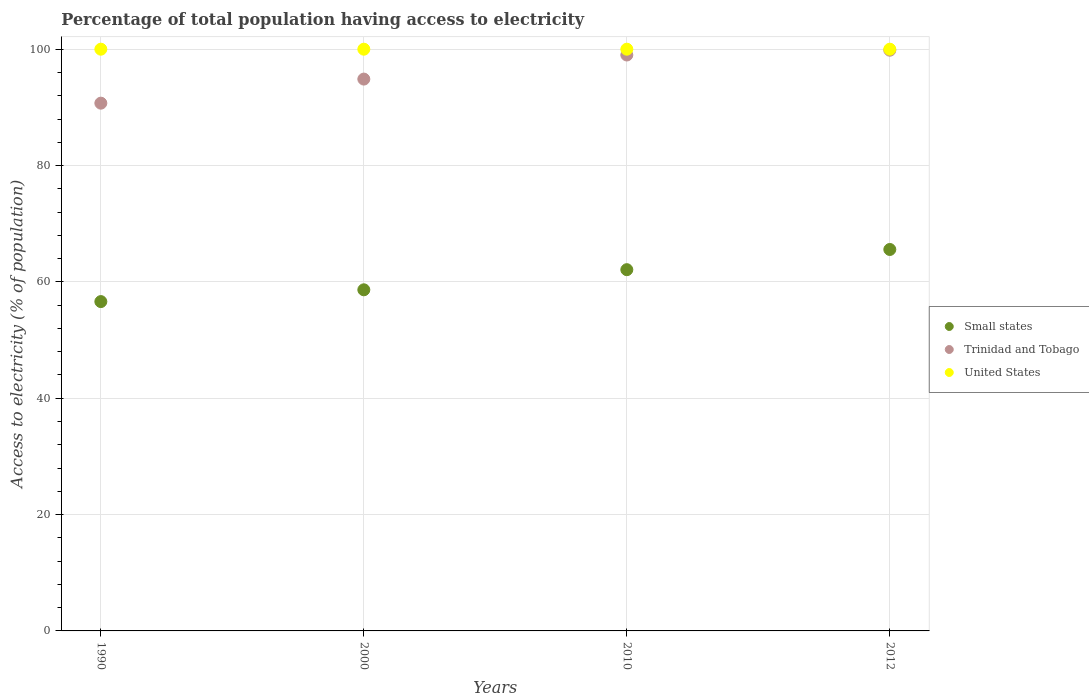What is the percentage of population that have access to electricity in Small states in 2000?
Your answer should be very brief. 58.64. Across all years, what is the maximum percentage of population that have access to electricity in Small states?
Make the answer very short. 65.57. Across all years, what is the minimum percentage of population that have access to electricity in Small states?
Ensure brevity in your answer.  56.61. In which year was the percentage of population that have access to electricity in Trinidad and Tobago maximum?
Provide a short and direct response. 2012. In which year was the percentage of population that have access to electricity in Small states minimum?
Make the answer very short. 1990. What is the total percentage of population that have access to electricity in United States in the graph?
Give a very brief answer. 400. What is the difference between the percentage of population that have access to electricity in United States in 1990 and that in 2012?
Ensure brevity in your answer.  0. What is the difference between the percentage of population that have access to electricity in Trinidad and Tobago in 2000 and the percentage of population that have access to electricity in Small states in 1990?
Ensure brevity in your answer.  38.25. What is the average percentage of population that have access to electricity in Small states per year?
Give a very brief answer. 60.73. In the year 1990, what is the difference between the percentage of population that have access to electricity in Small states and percentage of population that have access to electricity in Trinidad and Tobago?
Make the answer very short. -34.11. In how many years, is the percentage of population that have access to electricity in Small states greater than 40 %?
Provide a short and direct response. 4. What is the difference between the highest and the second highest percentage of population that have access to electricity in Trinidad and Tobago?
Your answer should be compact. 0.83. What is the difference between the highest and the lowest percentage of population that have access to electricity in United States?
Offer a terse response. 0. Is it the case that in every year, the sum of the percentage of population that have access to electricity in Small states and percentage of population that have access to electricity in Trinidad and Tobago  is greater than the percentage of population that have access to electricity in United States?
Your answer should be very brief. Yes. Is the percentage of population that have access to electricity in United States strictly less than the percentage of population that have access to electricity in Trinidad and Tobago over the years?
Your answer should be very brief. No. Does the graph contain grids?
Your answer should be very brief. Yes. How many legend labels are there?
Your answer should be very brief. 3. What is the title of the graph?
Your answer should be very brief. Percentage of total population having access to electricity. Does "Myanmar" appear as one of the legend labels in the graph?
Make the answer very short. No. What is the label or title of the X-axis?
Ensure brevity in your answer.  Years. What is the label or title of the Y-axis?
Provide a succinct answer. Access to electricity (% of population). What is the Access to electricity (% of population) of Small states in 1990?
Your answer should be compact. 56.61. What is the Access to electricity (% of population) in Trinidad and Tobago in 1990?
Give a very brief answer. 90.72. What is the Access to electricity (% of population) of United States in 1990?
Offer a terse response. 100. What is the Access to electricity (% of population) of Small states in 2000?
Provide a succinct answer. 58.64. What is the Access to electricity (% of population) in Trinidad and Tobago in 2000?
Offer a very short reply. 94.86. What is the Access to electricity (% of population) of Small states in 2010?
Provide a succinct answer. 62.1. What is the Access to electricity (% of population) in Trinidad and Tobago in 2010?
Offer a very short reply. 99. What is the Access to electricity (% of population) in Small states in 2012?
Ensure brevity in your answer.  65.57. What is the Access to electricity (% of population) of Trinidad and Tobago in 2012?
Your answer should be compact. 99.83. What is the Access to electricity (% of population) in United States in 2012?
Your answer should be compact. 100. Across all years, what is the maximum Access to electricity (% of population) in Small states?
Offer a terse response. 65.57. Across all years, what is the maximum Access to electricity (% of population) of Trinidad and Tobago?
Give a very brief answer. 99.83. Across all years, what is the maximum Access to electricity (% of population) in United States?
Ensure brevity in your answer.  100. Across all years, what is the minimum Access to electricity (% of population) in Small states?
Provide a succinct answer. 56.61. Across all years, what is the minimum Access to electricity (% of population) of Trinidad and Tobago?
Make the answer very short. 90.72. Across all years, what is the minimum Access to electricity (% of population) in United States?
Keep it short and to the point. 100. What is the total Access to electricity (% of population) of Small states in the graph?
Your response must be concise. 242.92. What is the total Access to electricity (% of population) in Trinidad and Tobago in the graph?
Give a very brief answer. 384.41. What is the total Access to electricity (% of population) in United States in the graph?
Your answer should be compact. 400. What is the difference between the Access to electricity (% of population) of Small states in 1990 and that in 2000?
Your answer should be compact. -2.03. What is the difference between the Access to electricity (% of population) of Trinidad and Tobago in 1990 and that in 2000?
Keep it short and to the point. -4.14. What is the difference between the Access to electricity (% of population) in Small states in 1990 and that in 2010?
Your answer should be compact. -5.49. What is the difference between the Access to electricity (% of population) in Trinidad and Tobago in 1990 and that in 2010?
Provide a short and direct response. -8.28. What is the difference between the Access to electricity (% of population) in Small states in 1990 and that in 2012?
Your response must be concise. -8.96. What is the difference between the Access to electricity (% of population) of Trinidad and Tobago in 1990 and that in 2012?
Provide a short and direct response. -9.11. What is the difference between the Access to electricity (% of population) in Small states in 2000 and that in 2010?
Make the answer very short. -3.46. What is the difference between the Access to electricity (% of population) in Trinidad and Tobago in 2000 and that in 2010?
Provide a succinct answer. -4.14. What is the difference between the Access to electricity (% of population) in United States in 2000 and that in 2010?
Offer a very short reply. 0. What is the difference between the Access to electricity (% of population) in Small states in 2000 and that in 2012?
Make the answer very short. -6.93. What is the difference between the Access to electricity (% of population) in Trinidad and Tobago in 2000 and that in 2012?
Keep it short and to the point. -4.97. What is the difference between the Access to electricity (% of population) of Small states in 2010 and that in 2012?
Your answer should be compact. -3.47. What is the difference between the Access to electricity (% of population) of Trinidad and Tobago in 2010 and that in 2012?
Provide a short and direct response. -0.83. What is the difference between the Access to electricity (% of population) of United States in 2010 and that in 2012?
Offer a very short reply. 0. What is the difference between the Access to electricity (% of population) in Small states in 1990 and the Access to electricity (% of population) in Trinidad and Tobago in 2000?
Make the answer very short. -38.25. What is the difference between the Access to electricity (% of population) of Small states in 1990 and the Access to electricity (% of population) of United States in 2000?
Offer a very short reply. -43.39. What is the difference between the Access to electricity (% of population) in Trinidad and Tobago in 1990 and the Access to electricity (% of population) in United States in 2000?
Make the answer very short. -9.28. What is the difference between the Access to electricity (% of population) of Small states in 1990 and the Access to electricity (% of population) of Trinidad and Tobago in 2010?
Your answer should be compact. -42.39. What is the difference between the Access to electricity (% of population) in Small states in 1990 and the Access to electricity (% of population) in United States in 2010?
Provide a short and direct response. -43.39. What is the difference between the Access to electricity (% of population) in Trinidad and Tobago in 1990 and the Access to electricity (% of population) in United States in 2010?
Your answer should be very brief. -9.28. What is the difference between the Access to electricity (% of population) in Small states in 1990 and the Access to electricity (% of population) in Trinidad and Tobago in 2012?
Make the answer very short. -43.22. What is the difference between the Access to electricity (% of population) in Small states in 1990 and the Access to electricity (% of population) in United States in 2012?
Provide a short and direct response. -43.39. What is the difference between the Access to electricity (% of population) in Trinidad and Tobago in 1990 and the Access to electricity (% of population) in United States in 2012?
Offer a terse response. -9.28. What is the difference between the Access to electricity (% of population) of Small states in 2000 and the Access to electricity (% of population) of Trinidad and Tobago in 2010?
Your response must be concise. -40.36. What is the difference between the Access to electricity (% of population) in Small states in 2000 and the Access to electricity (% of population) in United States in 2010?
Your response must be concise. -41.36. What is the difference between the Access to electricity (% of population) of Trinidad and Tobago in 2000 and the Access to electricity (% of population) of United States in 2010?
Make the answer very short. -5.14. What is the difference between the Access to electricity (% of population) in Small states in 2000 and the Access to electricity (% of population) in Trinidad and Tobago in 2012?
Keep it short and to the point. -41.19. What is the difference between the Access to electricity (% of population) of Small states in 2000 and the Access to electricity (% of population) of United States in 2012?
Offer a very short reply. -41.36. What is the difference between the Access to electricity (% of population) of Trinidad and Tobago in 2000 and the Access to electricity (% of population) of United States in 2012?
Provide a short and direct response. -5.14. What is the difference between the Access to electricity (% of population) of Small states in 2010 and the Access to electricity (% of population) of Trinidad and Tobago in 2012?
Your response must be concise. -37.73. What is the difference between the Access to electricity (% of population) of Small states in 2010 and the Access to electricity (% of population) of United States in 2012?
Give a very brief answer. -37.9. What is the difference between the Access to electricity (% of population) of Trinidad and Tobago in 2010 and the Access to electricity (% of population) of United States in 2012?
Offer a terse response. -1. What is the average Access to electricity (% of population) in Small states per year?
Provide a short and direct response. 60.73. What is the average Access to electricity (% of population) in Trinidad and Tobago per year?
Your response must be concise. 96.1. What is the average Access to electricity (% of population) of United States per year?
Your answer should be very brief. 100. In the year 1990, what is the difference between the Access to electricity (% of population) in Small states and Access to electricity (% of population) in Trinidad and Tobago?
Provide a succinct answer. -34.11. In the year 1990, what is the difference between the Access to electricity (% of population) in Small states and Access to electricity (% of population) in United States?
Make the answer very short. -43.39. In the year 1990, what is the difference between the Access to electricity (% of population) of Trinidad and Tobago and Access to electricity (% of population) of United States?
Provide a succinct answer. -9.28. In the year 2000, what is the difference between the Access to electricity (% of population) of Small states and Access to electricity (% of population) of Trinidad and Tobago?
Make the answer very short. -36.22. In the year 2000, what is the difference between the Access to electricity (% of population) of Small states and Access to electricity (% of population) of United States?
Give a very brief answer. -41.36. In the year 2000, what is the difference between the Access to electricity (% of population) in Trinidad and Tobago and Access to electricity (% of population) in United States?
Your answer should be very brief. -5.14. In the year 2010, what is the difference between the Access to electricity (% of population) of Small states and Access to electricity (% of population) of Trinidad and Tobago?
Make the answer very short. -36.9. In the year 2010, what is the difference between the Access to electricity (% of population) in Small states and Access to electricity (% of population) in United States?
Make the answer very short. -37.9. In the year 2010, what is the difference between the Access to electricity (% of population) of Trinidad and Tobago and Access to electricity (% of population) of United States?
Your answer should be very brief. -1. In the year 2012, what is the difference between the Access to electricity (% of population) of Small states and Access to electricity (% of population) of Trinidad and Tobago?
Your answer should be very brief. -34.26. In the year 2012, what is the difference between the Access to electricity (% of population) in Small states and Access to electricity (% of population) in United States?
Your response must be concise. -34.43. In the year 2012, what is the difference between the Access to electricity (% of population) of Trinidad and Tobago and Access to electricity (% of population) of United States?
Offer a terse response. -0.17. What is the ratio of the Access to electricity (% of population) in Small states in 1990 to that in 2000?
Ensure brevity in your answer.  0.97. What is the ratio of the Access to electricity (% of population) in Trinidad and Tobago in 1990 to that in 2000?
Provide a succinct answer. 0.96. What is the ratio of the Access to electricity (% of population) in Small states in 1990 to that in 2010?
Keep it short and to the point. 0.91. What is the ratio of the Access to electricity (% of population) in Trinidad and Tobago in 1990 to that in 2010?
Ensure brevity in your answer.  0.92. What is the ratio of the Access to electricity (% of population) in United States in 1990 to that in 2010?
Keep it short and to the point. 1. What is the ratio of the Access to electricity (% of population) in Small states in 1990 to that in 2012?
Make the answer very short. 0.86. What is the ratio of the Access to electricity (% of population) of Trinidad and Tobago in 1990 to that in 2012?
Your answer should be very brief. 0.91. What is the ratio of the Access to electricity (% of population) in United States in 1990 to that in 2012?
Ensure brevity in your answer.  1. What is the ratio of the Access to electricity (% of population) in Small states in 2000 to that in 2010?
Your answer should be very brief. 0.94. What is the ratio of the Access to electricity (% of population) of Trinidad and Tobago in 2000 to that in 2010?
Keep it short and to the point. 0.96. What is the ratio of the Access to electricity (% of population) of United States in 2000 to that in 2010?
Provide a succinct answer. 1. What is the ratio of the Access to electricity (% of population) in Small states in 2000 to that in 2012?
Provide a succinct answer. 0.89. What is the ratio of the Access to electricity (% of population) of Trinidad and Tobago in 2000 to that in 2012?
Provide a short and direct response. 0.95. What is the ratio of the Access to electricity (% of population) of Small states in 2010 to that in 2012?
Your answer should be compact. 0.95. What is the ratio of the Access to electricity (% of population) in United States in 2010 to that in 2012?
Your answer should be very brief. 1. What is the difference between the highest and the second highest Access to electricity (% of population) in Small states?
Give a very brief answer. 3.47. What is the difference between the highest and the second highest Access to electricity (% of population) of Trinidad and Tobago?
Provide a succinct answer. 0.83. What is the difference between the highest and the second highest Access to electricity (% of population) of United States?
Provide a short and direct response. 0. What is the difference between the highest and the lowest Access to electricity (% of population) of Small states?
Provide a short and direct response. 8.96. What is the difference between the highest and the lowest Access to electricity (% of population) of Trinidad and Tobago?
Offer a terse response. 9.11. What is the difference between the highest and the lowest Access to electricity (% of population) of United States?
Your answer should be very brief. 0. 